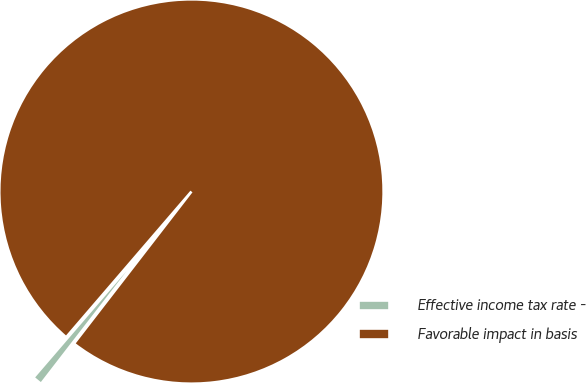Convert chart. <chart><loc_0><loc_0><loc_500><loc_500><pie_chart><fcel>Effective income tax rate -<fcel>Favorable impact in basis<nl><fcel>0.83%<fcel>99.17%<nl></chart> 